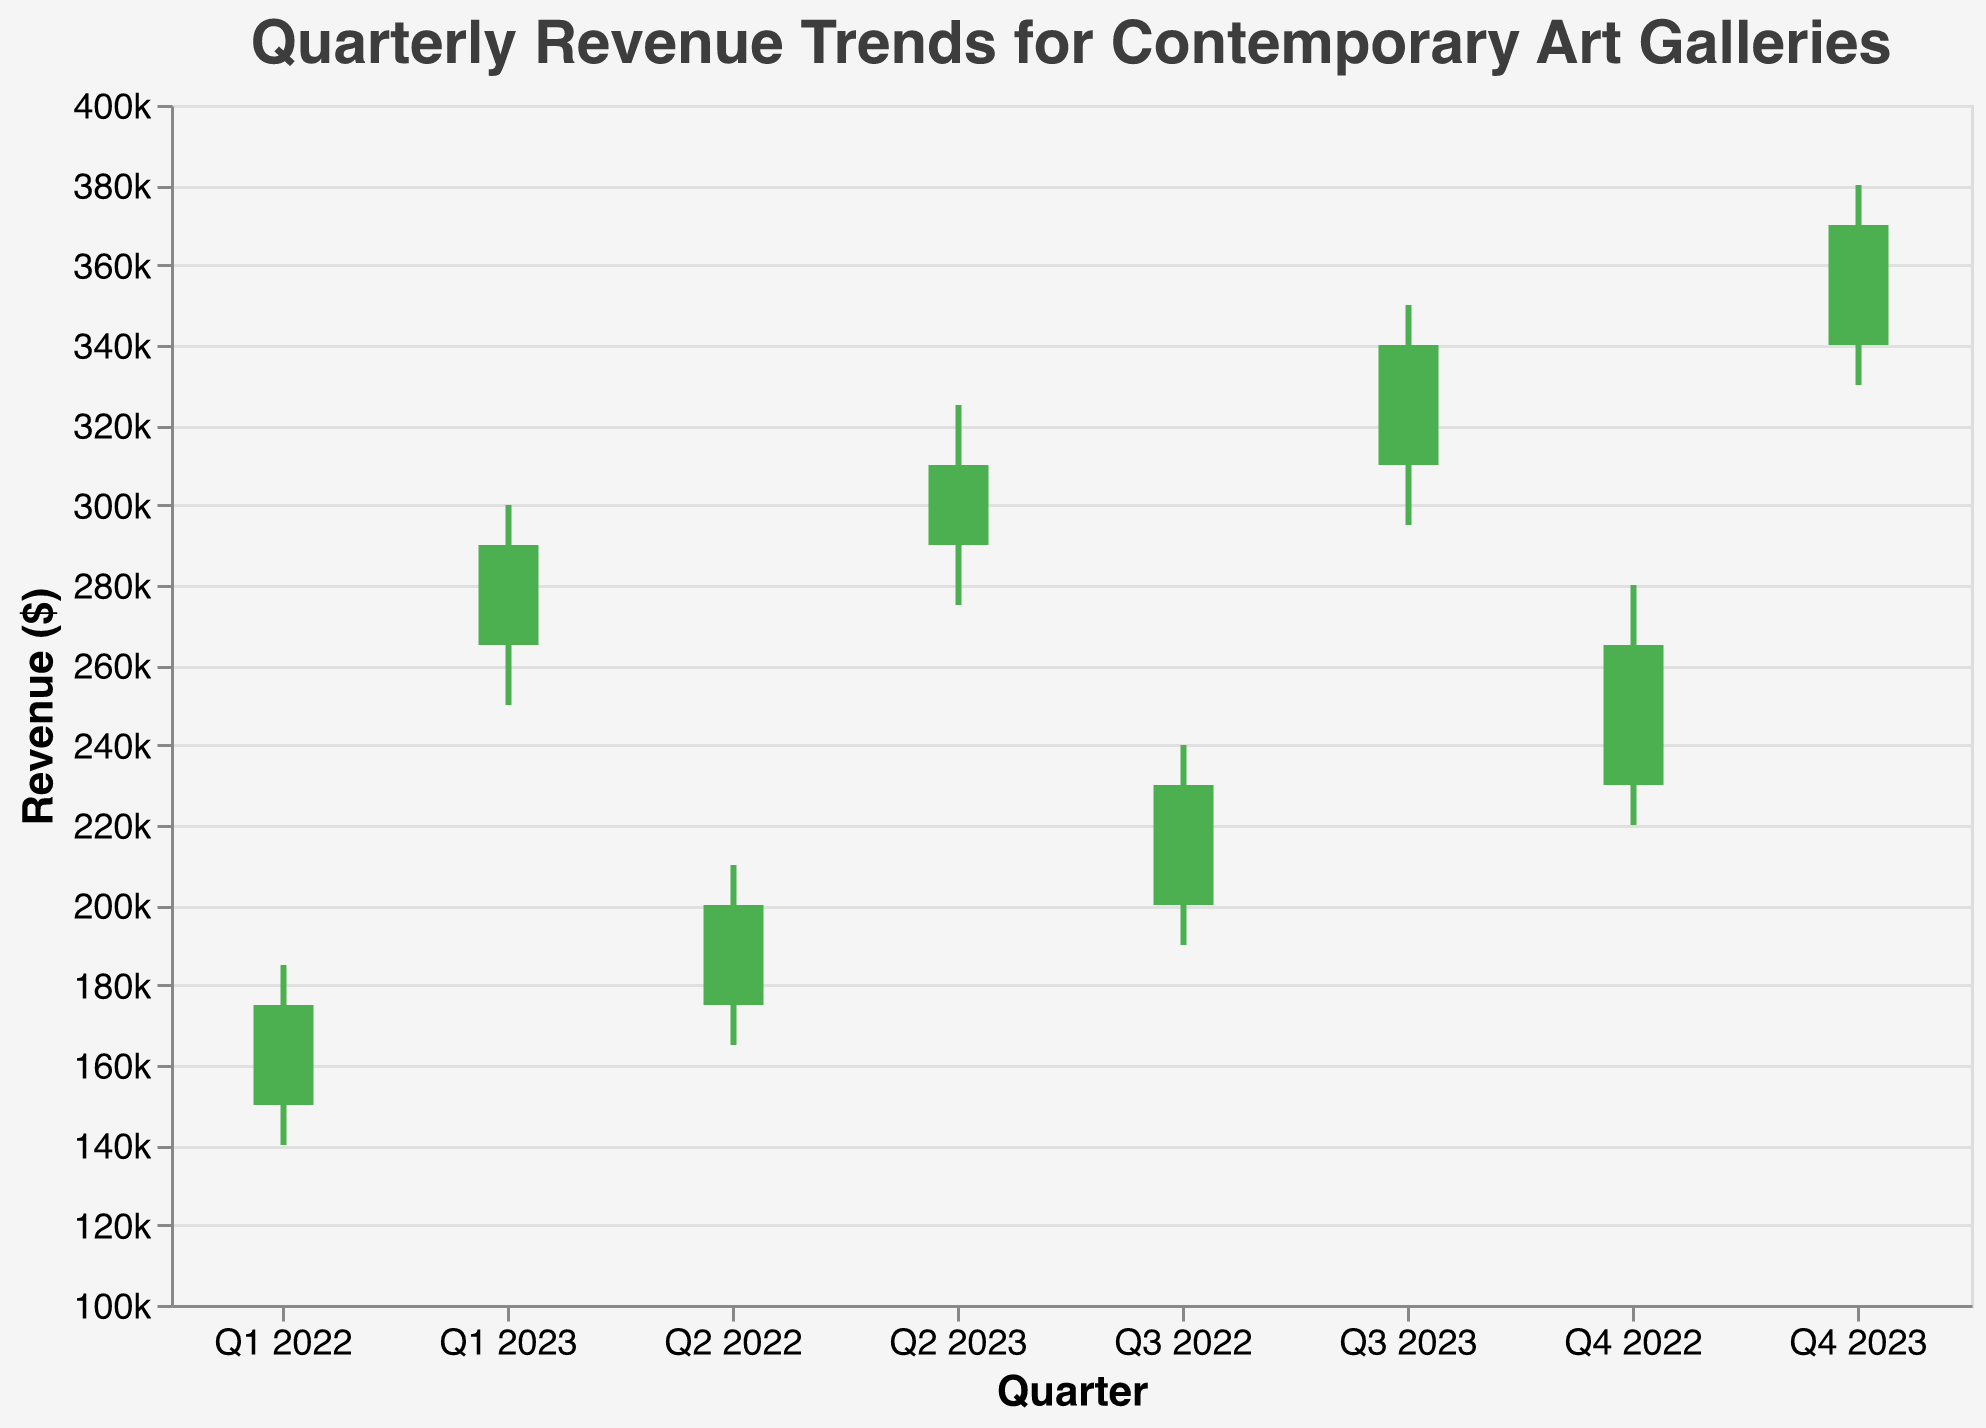What's the title of the figure? The title of the figure is displayed at the top and reads "Quarterly Revenue Trends for Contemporary Art Galleries."
Answer: Quarterly Revenue Trends for Contemporary Art Galleries In which quarter of 2022 was the revenue at its lowest for any given quarter? The lowest revenue for any quarter in 2022 can be found by looking at the "Low" values. Q1 2022 has the lowest "Low" value of 140,000.
Answer: Q1 2022 What was the highest revenue achieved in 2023? The highest revenue can be found by looking at the "High" values. The maximum "High" value for 2023 is 380,000 in Q4 2023.
Answer: 380,000 In which quarter did the revenue increase the most compared to the previous quarter? To determine this, we look at the difference between the "Close" values from one quarter to the next. The largest increase is between Q4 2022 and Q1 2023 (290,000 - 265,000 = 25,000).
Answer: Q1 2023 Compare the closing revenue of Q2 2022 with Q4 2022. Did the revenue increase or decrease, and by how much? The closing revenue in Q2 2022 is 200,000, and in Q4 2022, it is 265,000. The difference is 265,000 - 200,000 = 65,000, an increase.
Answer: Increase, 65,000 Is there any quarter where the opening revenue was higher than the closing revenue? To determine this, we compare the "Open" and "Close" values for all quarters. In all quarters, the "Close" value is higher than the "Open" value.
Answer: No What is the average high revenue for the year 2023? The high revenues for 2023 are 300,000, 325,000, 350,000, and 380,000. To find the average: (300,000 + 325,000 + 350,000 + 380,000) / 4 = 338,750.
Answer: 338,750 Which quarter in 2023 had the smallest range between high and low revenues? The range is calculated by subtracting the "Low" value from the "High" value. The smallest range is in Q4 2023: 380,000 - 330,000 = 50,000.
Answer: Q4 2023 